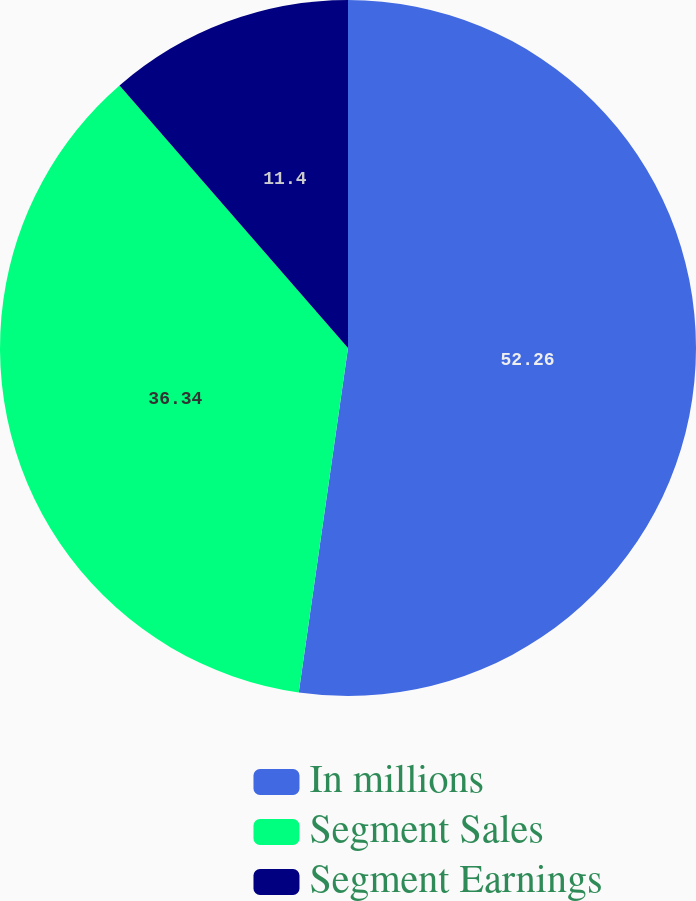Convert chart. <chart><loc_0><loc_0><loc_500><loc_500><pie_chart><fcel>In millions<fcel>Segment Sales<fcel>Segment Earnings<nl><fcel>52.26%<fcel>36.34%<fcel>11.4%<nl></chart> 